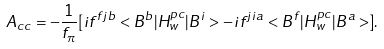<formula> <loc_0><loc_0><loc_500><loc_500>A _ { c c } = - \frac { 1 } { f _ { \pi } } [ i f ^ { f j b } < B ^ { b } | H ^ { p c } _ { w } | B ^ { i } > - i f ^ { j i a } < B ^ { f } | H ^ { p c } _ { w } | B ^ { a } > ] .</formula> 